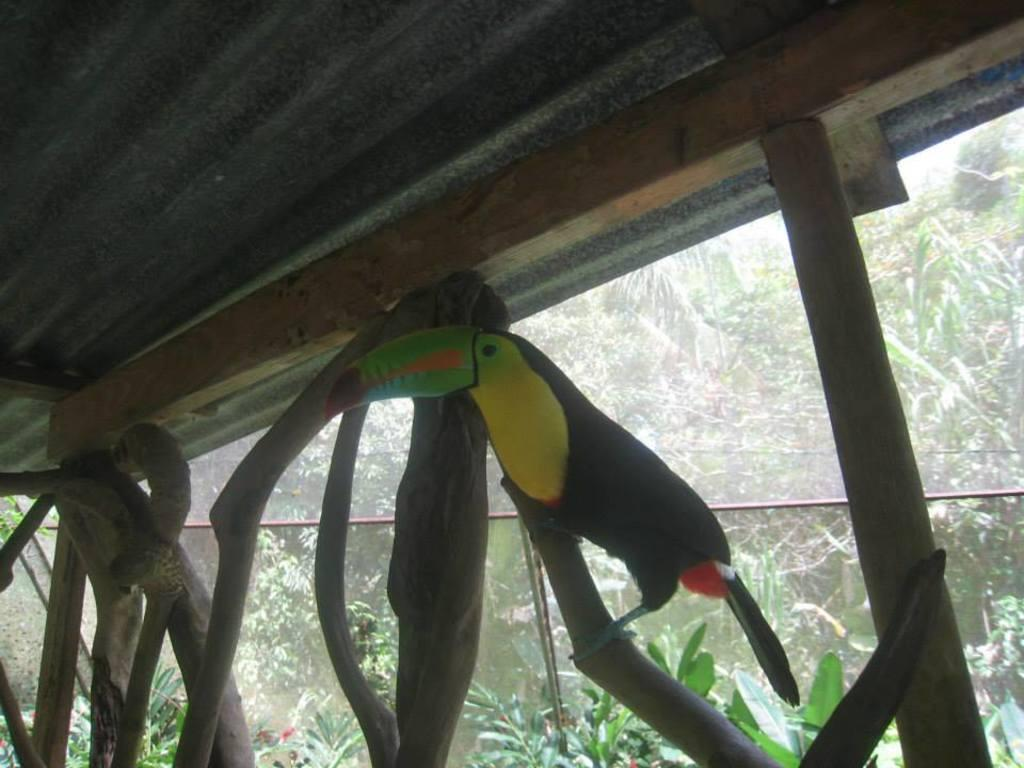What is on top of the wooden pole in the image? There is a bird on a wooden pole in the image. How many wooden poles are visible in the image? There are multiple wooden poles in the image. What can be seen in the background of the image? There are many plants and trees in the background of the image. What type of pies are being baked in the houses in the image? There are no houses or pies present in the image; it features a bird on a wooden pole and multiple wooden poles with plants and trees in the background. 